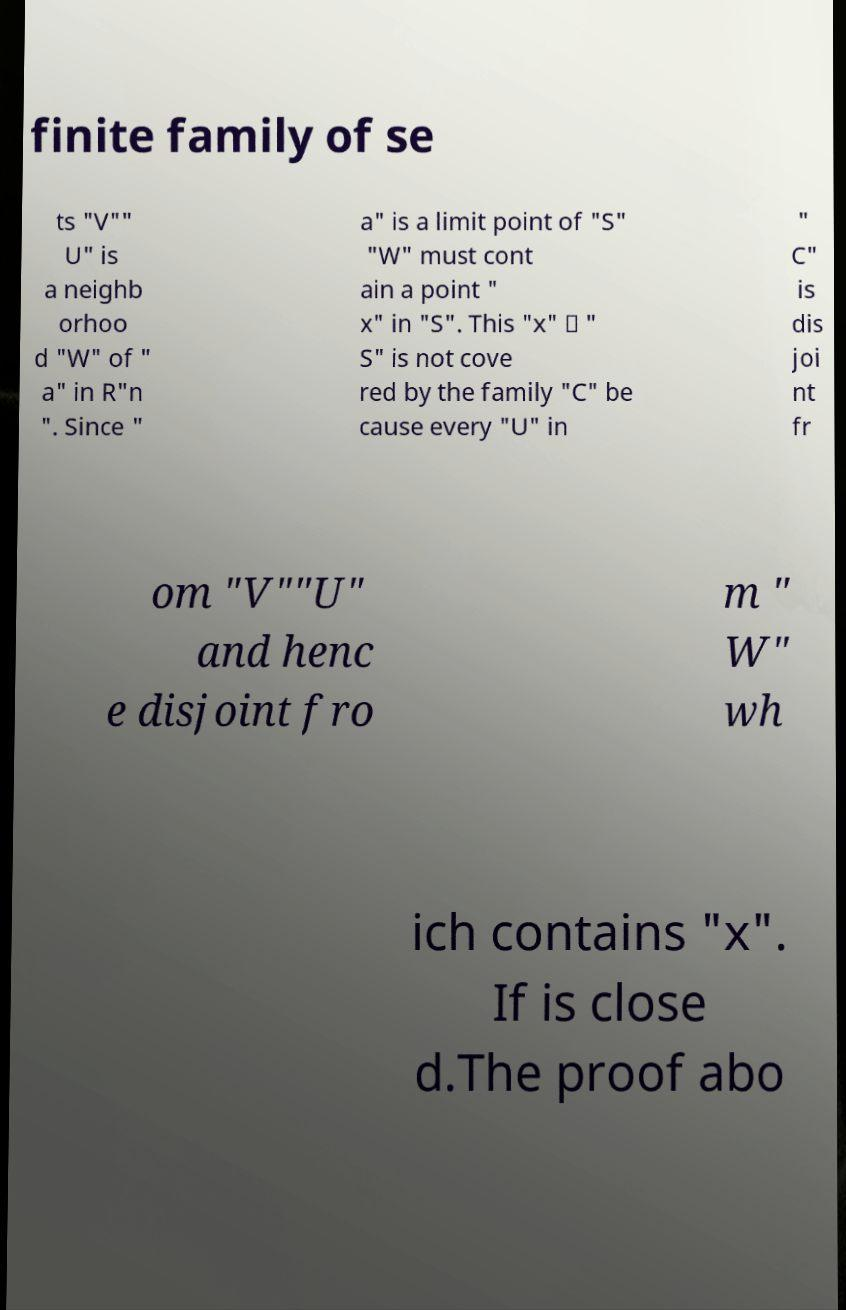Could you extract and type out the text from this image? finite family of se ts "V"" U" is a neighb orhoo d "W" of " a" in R"n ". Since " a" is a limit point of "S" "W" must cont ain a point " x" in "S". This "x" ∈ " S" is not cove red by the family "C" be cause every "U" in " C" is dis joi nt fr om "V""U" and henc e disjoint fro m " W" wh ich contains "x". If is close d.The proof abo 